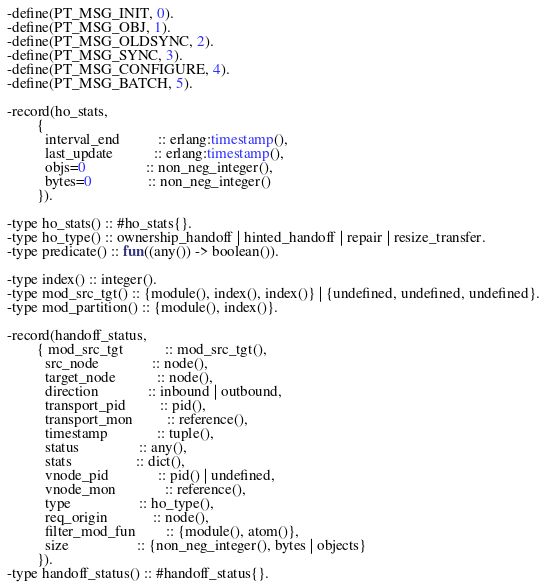Convert code to text. <code><loc_0><loc_0><loc_500><loc_500><_Erlang_>-define(PT_MSG_INIT, 0).
-define(PT_MSG_OBJ, 1).
-define(PT_MSG_OLDSYNC, 2).
-define(PT_MSG_SYNC, 3).
-define(PT_MSG_CONFIGURE, 4).
-define(PT_MSG_BATCH, 5).

-record(ho_stats,
        {
          interval_end          :: erlang:timestamp(),
          last_update           :: erlang:timestamp(),
          objs=0                :: non_neg_integer(),
          bytes=0               :: non_neg_integer()
        }).

-type ho_stats() :: #ho_stats{}.
-type ho_type() :: ownership_handoff | hinted_handoff | repair | resize_transfer.
-type predicate() :: fun((any()) -> boolean()).

-type index() :: integer().
-type mod_src_tgt() :: {module(), index(), index()} | {undefined, undefined, undefined}.
-type mod_partition() :: {module(), index()}.

-record(handoff_status,
        { mod_src_tgt           :: mod_src_tgt(),
          src_node              :: node(),
          target_node           :: node(),
          direction             :: inbound | outbound,
          transport_pid         :: pid(),
          transport_mon         :: reference(),
          timestamp             :: tuple(),
          status                :: any(),
          stats                 :: dict(),
          vnode_pid             :: pid() | undefined,
          vnode_mon             :: reference(),
          type                  :: ho_type(),
          req_origin            :: node(),
          filter_mod_fun        :: {module(), atom()},
          size                  :: {non_neg_integer(), bytes | objects}
        }).
-type handoff_status() :: #handoff_status{}.
</code> 